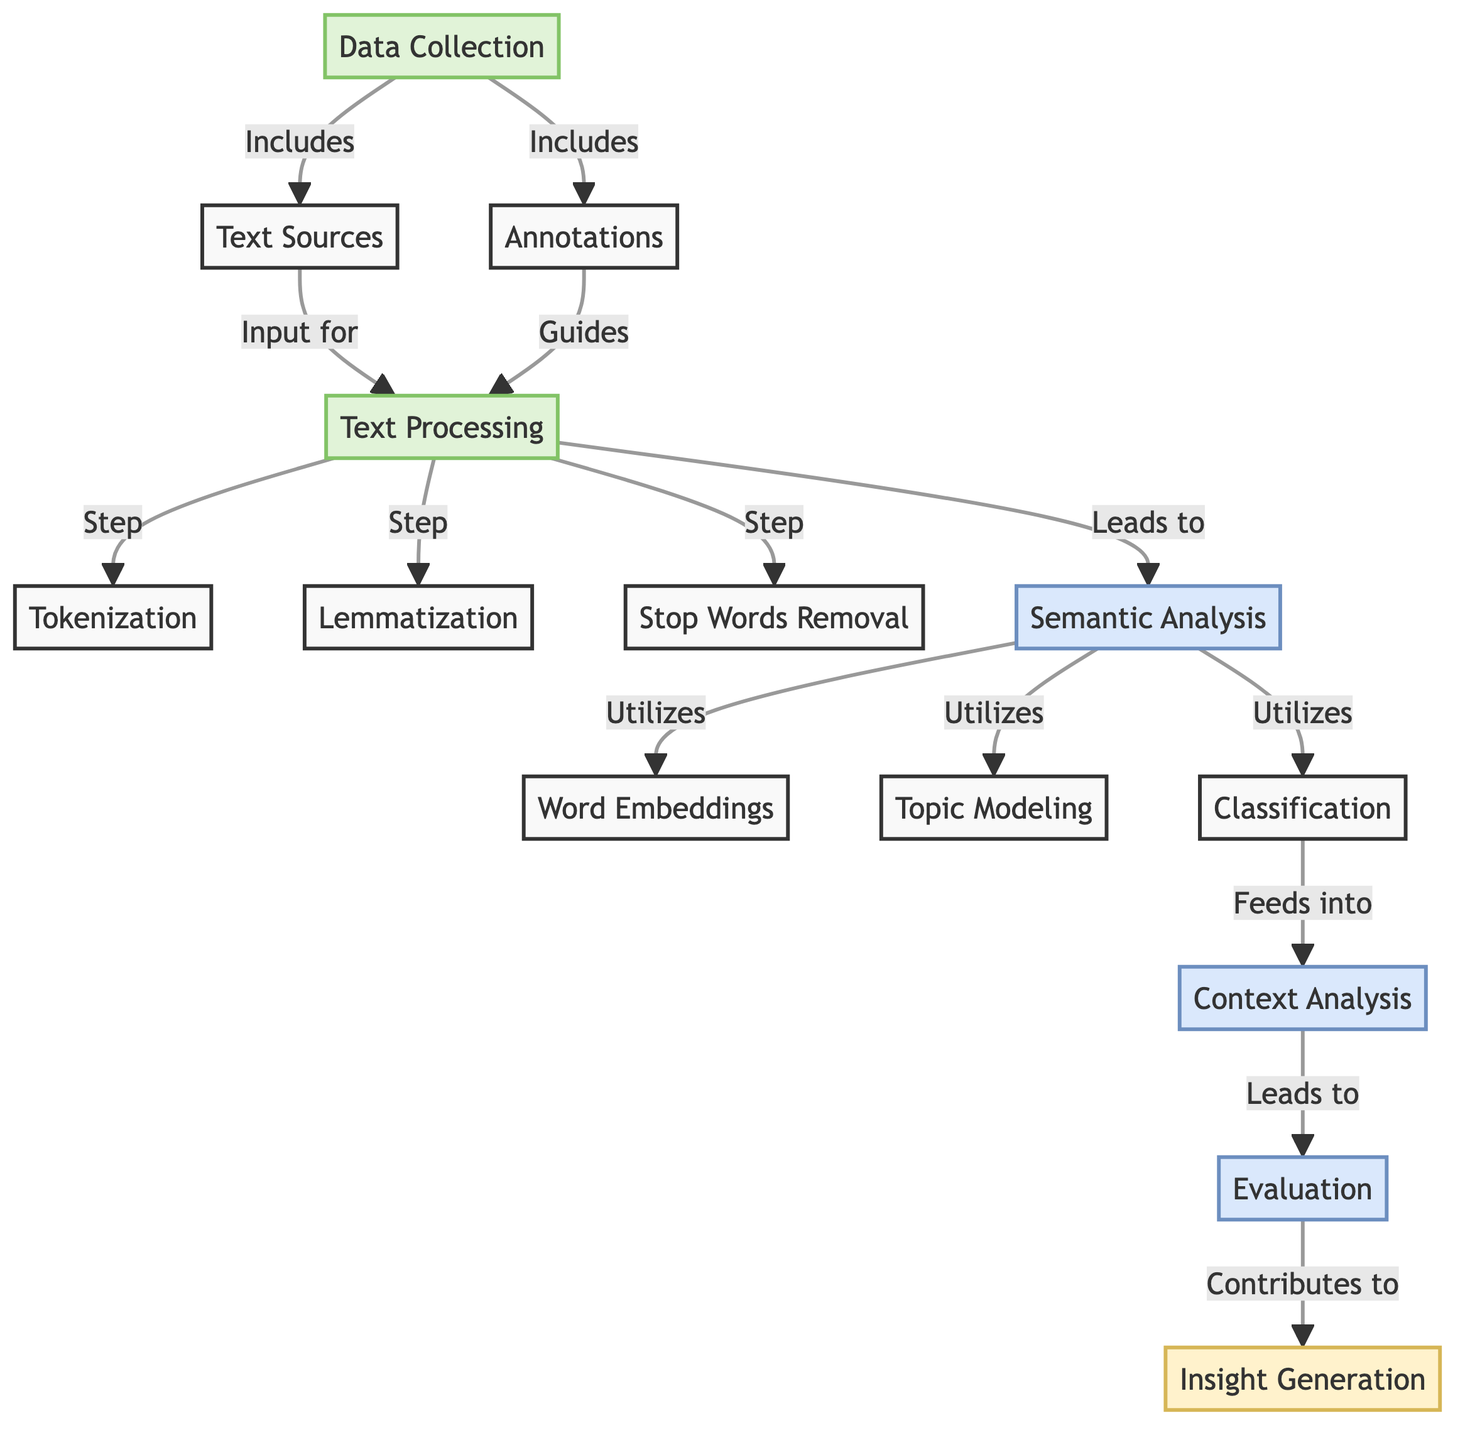What is the starting point of the flow in this diagram? The starting point is the node labeled "Data Collection," which is the first step in the process as indicated by its connection to other nodes in the flowchart.
Answer: Data Collection How many main processes are depicted in the diagram? The diagram shows four main processes: Data Collection, Text Processing, Semantic Analysis, and Context Analysis. These are visually represented as process nodes.
Answer: Four What does the "Semantic Analysis" node utilize? The "Semantic Analysis" node utilizes three components: Word Embeddings, Topic Modeling, and Classification, as demonstrated by its connections to these nodes.
Answer: Word Embeddings, Topic Modeling, Classification Which node contributes to "Insight Generation"? The node that contributes to "Insight Generation" is "Evaluation," which flows into the final output node in the diagram.
Answer: Evaluation What is the relationship between "Text Sources" and "Text Processing"? "Text Sources" serves as an input for "Text Processing," indicating that the output from the "Text Sources" node is required to perform the subsequent processing steps.
Answer: Input for How does "Classification" affect the overall analysis process? "Classification" feeds into "Context Analysis," indicating that the results of the classification step are essential for understanding the context of the texts being analyzed, thus influencing the subsequent evaluation.
Answer: Feeds into What type of analysis is indicated as a critical part of the process after "Semantic Analysis"? After "Semantic Analysis," the critical part of the process is "Context Analysis," indicated by the directional flow from the semantic analysis node to the context analysis node.
Answer: Context Analysis What does the "Word Embeddings" node relate to? The "Word Embeddings" node relates to "Semantic Analysis" as it is utilized within that analytical process to derive meaning from the text.
Answer: Semantic Analysis Which nodes directly lead to the "Insight Generation"? The nodes that lead to "Insight Generation" are "Evaluation," which connects directly to it and provides the necessary insights after assessing the context.
Answer: Evaluation 